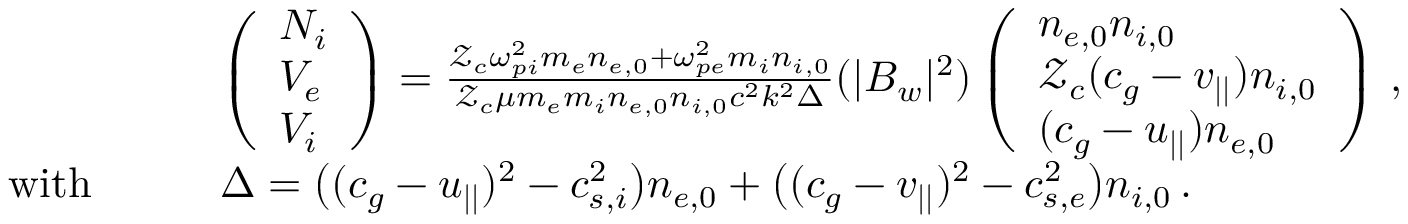<formula> <loc_0><loc_0><loc_500><loc_500>\begin{array} { r l } & { \left ( \begin{array} { l } { N _ { i } } \\ { V _ { e } } \\ { V _ { i } } \end{array} \right ) = \frac { \mathcal { Z } _ { c } \omega _ { p i } ^ { 2 } m _ { e } n _ { e , 0 } + \omega _ { p e } ^ { 2 } m _ { i } n _ { i , 0 } } { \mathcal { Z } _ { c } \mu m _ { e } m _ { i } n _ { e , 0 } n _ { i , 0 } c ^ { 2 } k ^ { 2 } \Delta } ( | B _ { w } | ^ { 2 } ) \left ( \begin{array} { l } { n _ { e , 0 } n _ { i , 0 } } \\ { \mathcal { Z } _ { c } ( c _ { g } - v _ { | | } ) n _ { i , 0 } } \\ { ( c _ { g } - u _ { | | } ) n _ { e , 0 } } \end{array} \right ) \, , } \\ { w i t h \quad } & { \Delta = \left ( ( c _ { g } - u _ { | | } ) ^ { 2 } - c _ { s , i } ^ { 2 } \right ) n _ { e , 0 } + \left ( ( c _ { g } - v _ { | | } ) ^ { 2 } - c _ { s , e } ^ { 2 } \right ) n _ { i , 0 } \, . } \end{array}</formula> 